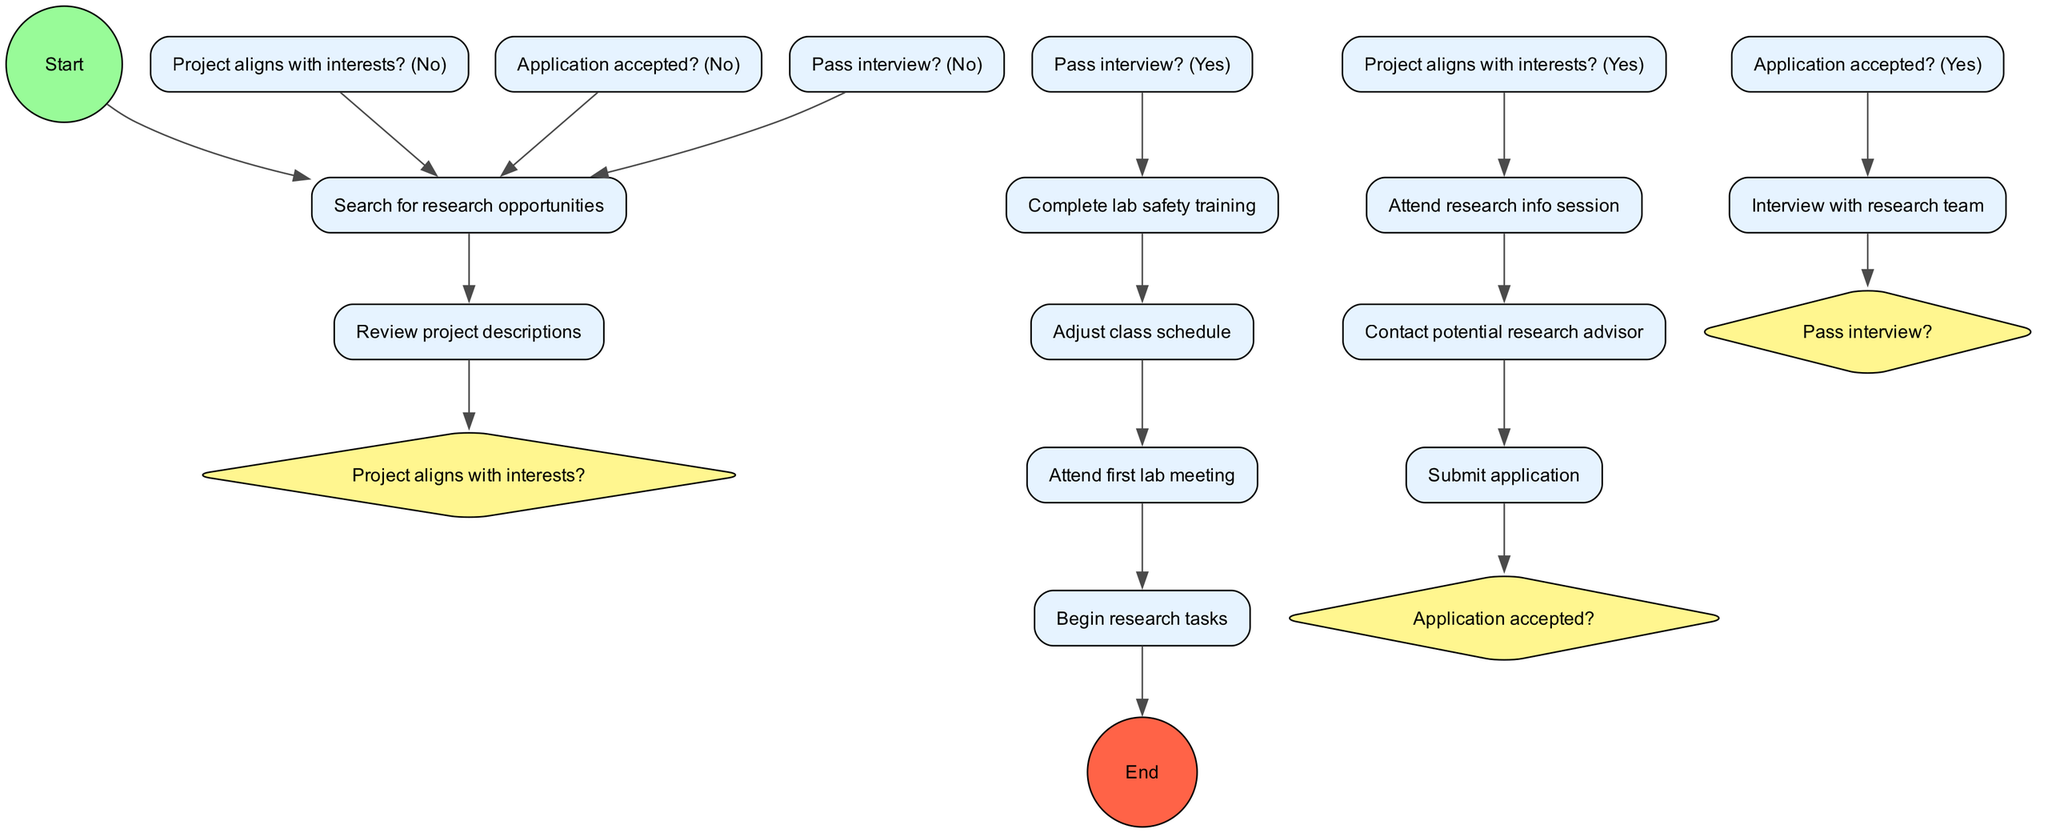What is the starting activity in this process? The initial node labeled "Start" connects to the first activity "Search for research opportunities," indicating that this is the starting step in the process.
Answer: Search for research opportunities How many decision nodes are in the diagram? There are three decision nodes: "Project aligns with interests?", "Application accepted?", and "Pass interview?". Counting these gives a total of three decision nodes.
Answer: 3 What is the first activity after the application is accepted? Following the decision "Application accepted?" where the answer is "Yes", the next step shown is "Interview with research team."
Answer: Interview with research team If a student passes the interview, what is the next required step? If the "Pass interview?" decision is "Yes," the subsequent step is "Complete lab safety training," which is clearly outlined in the flow.
Answer: Complete lab safety training How many activities are listed in the diagram? The diagram includes ten distinct activities that need to be accomplished as part of the research project joining process, which can be counted directly from the activities section.
Answer: 10 What happens if the project does not align with the student's interests? If the decision "Project aligns with interests?" is "No," the flow leads back to the activity "Search for research opportunities," indicating that the student must look for other opportunities.
Answer: Search for research opportunities What is the endpoint of the entire process? The final node of the diagram is labeled "End," indicating the completion of the entire process after the research tasks have begun.
Answer: End Which step comes after attending the first lab meeting? Following the activity "Attend first lab meeting," the next step directly indicated is "Begin research tasks," marking the transition into practical research activities.
Answer: Begin research tasks 